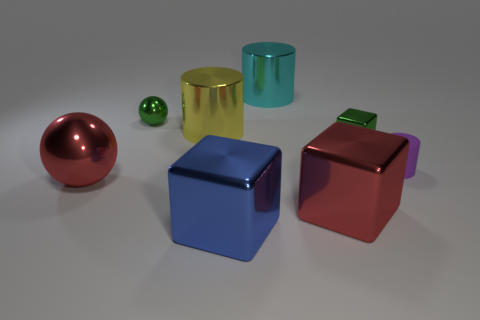How many other objects are the same material as the green block?
Your response must be concise. 6. There is a blue object that is the same material as the yellow cylinder; what shape is it?
Your response must be concise. Cube. Are there any other things of the same color as the small ball?
Provide a succinct answer. Yes. The thing that is the same color as the large ball is what size?
Your response must be concise. Large. Is the number of green cubes that are in front of the green ball greater than the number of brown spheres?
Give a very brief answer. Yes. Do the yellow metallic object and the shiny thing behind the tiny metal ball have the same shape?
Your answer should be very brief. Yes. What number of red metallic spheres are the same size as the cyan shiny cylinder?
Ensure brevity in your answer.  1. How many tiny purple rubber cylinders are behind the tiny object behind the block that is behind the rubber thing?
Ensure brevity in your answer.  0. Are there the same number of big red spheres behind the large red shiny ball and green things to the left of the big yellow thing?
Make the answer very short. No. What number of blue things are the same shape as the big cyan thing?
Give a very brief answer. 0. 